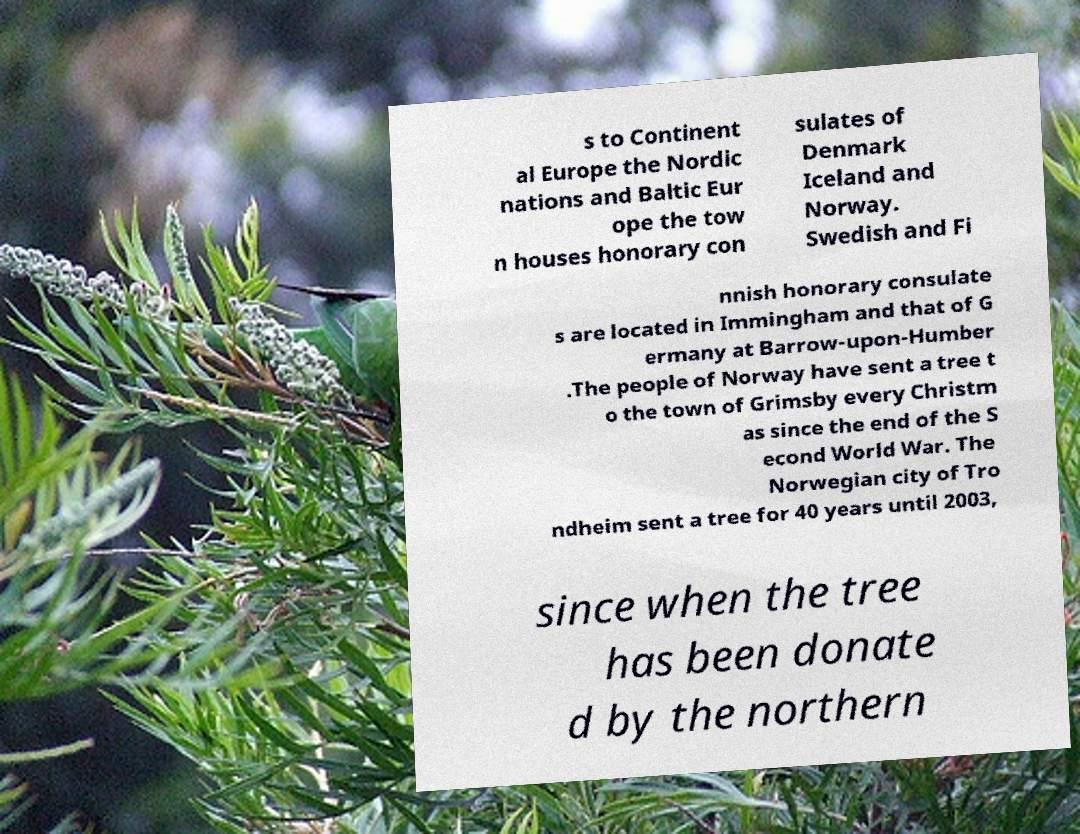Could you assist in decoding the text presented in this image and type it out clearly? s to Continent al Europe the Nordic nations and Baltic Eur ope the tow n houses honorary con sulates of Denmark Iceland and Norway. Swedish and Fi nnish honorary consulate s are located in Immingham and that of G ermany at Barrow-upon-Humber .The people of Norway have sent a tree t o the town of Grimsby every Christm as since the end of the S econd World War. The Norwegian city of Tro ndheim sent a tree for 40 years until 2003, since when the tree has been donate d by the northern 